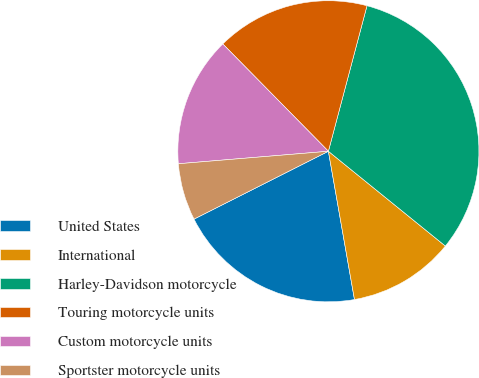<chart> <loc_0><loc_0><loc_500><loc_500><pie_chart><fcel>United States<fcel>International<fcel>Harley-Davidson motorcycle<fcel>Touring motorcycle units<fcel>Custom motorcycle units<fcel>Sportster motorcycle units<nl><fcel>20.33%<fcel>11.39%<fcel>31.71%<fcel>16.5%<fcel>13.95%<fcel>6.12%<nl></chart> 